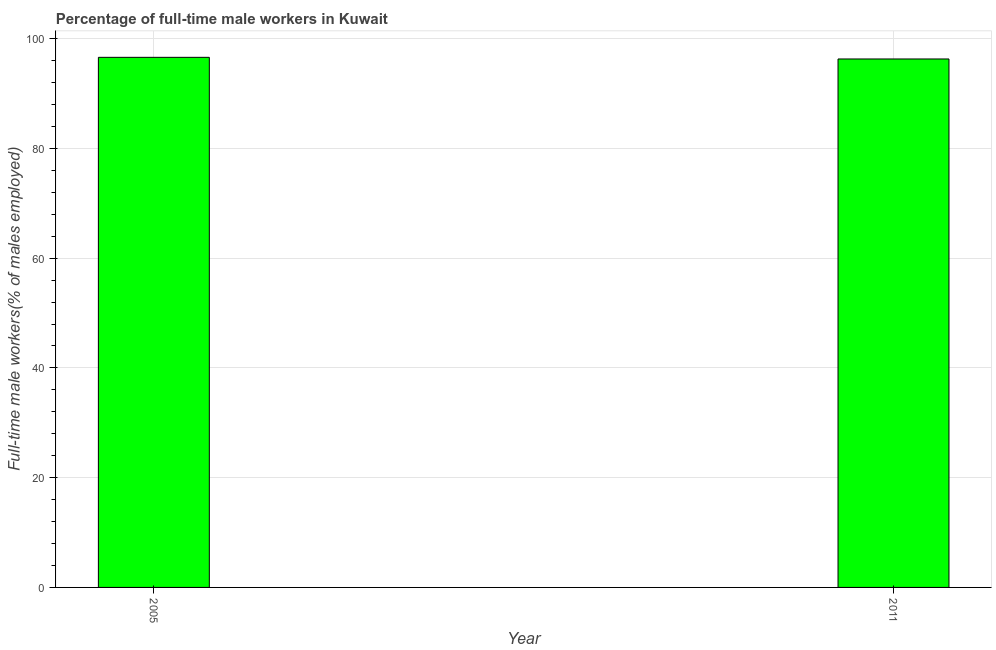Does the graph contain grids?
Your answer should be compact. Yes. What is the title of the graph?
Make the answer very short. Percentage of full-time male workers in Kuwait. What is the label or title of the Y-axis?
Ensure brevity in your answer.  Full-time male workers(% of males employed). What is the percentage of full-time male workers in 2011?
Your response must be concise. 96.3. Across all years, what is the maximum percentage of full-time male workers?
Keep it short and to the point. 96.6. Across all years, what is the minimum percentage of full-time male workers?
Your answer should be very brief. 96.3. What is the sum of the percentage of full-time male workers?
Give a very brief answer. 192.9. What is the difference between the percentage of full-time male workers in 2005 and 2011?
Ensure brevity in your answer.  0.3. What is the average percentage of full-time male workers per year?
Your answer should be very brief. 96.45. What is the median percentage of full-time male workers?
Offer a very short reply. 96.45. What is the ratio of the percentage of full-time male workers in 2005 to that in 2011?
Ensure brevity in your answer.  1. Is the percentage of full-time male workers in 2005 less than that in 2011?
Provide a succinct answer. No. How many bars are there?
Your answer should be compact. 2. Are the values on the major ticks of Y-axis written in scientific E-notation?
Offer a terse response. No. What is the Full-time male workers(% of males employed) in 2005?
Ensure brevity in your answer.  96.6. What is the Full-time male workers(% of males employed) of 2011?
Provide a succinct answer. 96.3. What is the ratio of the Full-time male workers(% of males employed) in 2005 to that in 2011?
Make the answer very short. 1. 